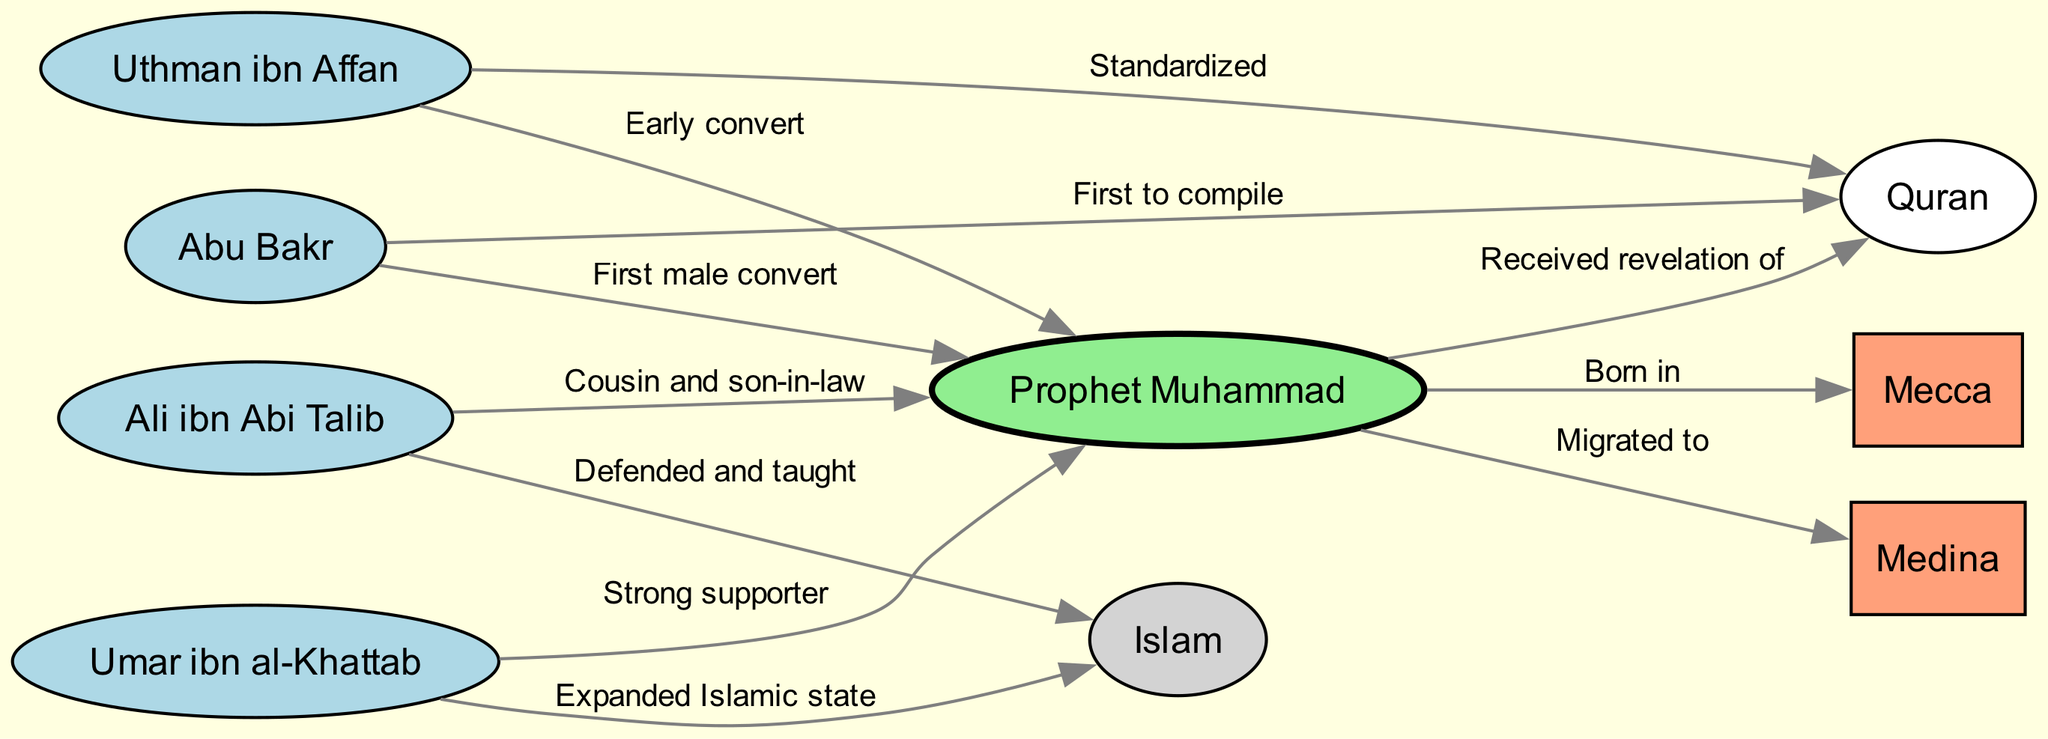What city was Prophet Muhammad born in? The diagram directly shows a connection from the "Muhammad" node to the "Mecca" node labeled "Born in". This indicates that Prophet Muhammad was born in Mecca.
Answer: Mecca Who was the first male convert to Islam? The diagram presents a direct edge from "Abu Bakr" to "Muhammad" labeled "First male convert," which identifies Abu Bakr as the first male convert to Islam.
Answer: Abu Bakr Which companion was known for his strong support of Muhammad? The connection from "Umar" to "Muhammad" labeled "Strong supporter" indicates that Umar was well-known for his strong support of the Prophet.
Answer: Umar How many companions are listed in the diagram? The diagram includes five distinct companions: Abu Bakr, Umar, Uthman, Ali, and the Prophet Muhammad himself. Therefore, the total number of companions listed is five.
Answer: Five What significant role did Abu Bakr play in relation to the Quran? One edge from "Abu Bakr" to "Quran" labeled "First to compile" signifies that Abu Bakr played a crucial role in compiling the Quran.
Answer: First to compile Which city did Muhammad migrate to? The diagram indicates a connection from "Muhammad" to "Medina" labeled "Migrated to," showing that he migrated to this city.
Answer: Medina How did Uthman contribute to the Quran? The edge from "Uthman" to "Quran" with the label "Standardized" indicates that Uthman contributed by standardizing the Quran.
Answer: Standardized What was Ali's relationship to Muhammad? The edge from "Ali" to "Muhammad" is labeled "Cousin and son-in-law," indicating that Ali held this familial relationship with Muhammad.
Answer: Cousin and son-in-law In what way did Umar influence the Islamic state? The connection from "Umar" to "Islam" with the label "Expanded Islamic state" indicates that Umar had a significant influence through the expansion of the Islamic state.
Answer: Expanded Islamic state 